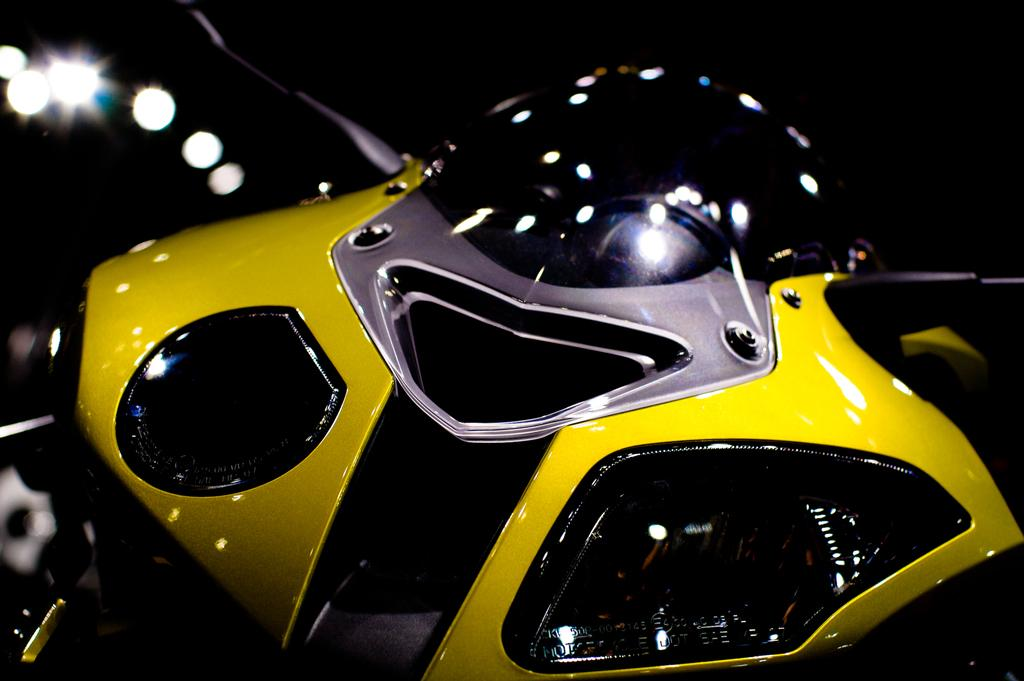What is the main subject of the picture? The main subject of the picture is a motorbike. What else can be seen in the picture besides the motorbike? There are lights visible in the picture. Can you hear the sound of the brothers playing in the sand in the picture? There is no sound, hearing, sand, or brothers mentioned or depicted in the picture. 